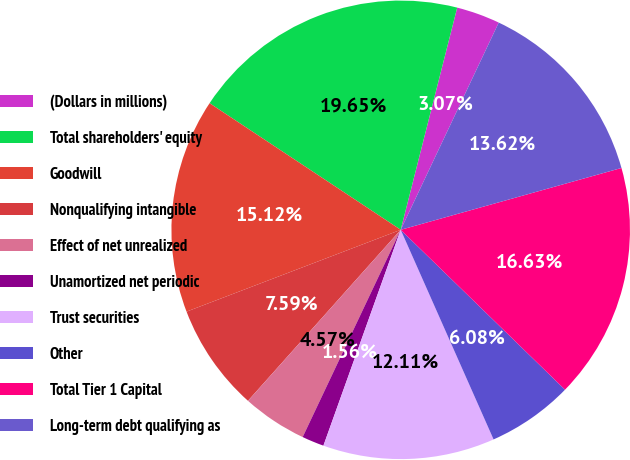Convert chart. <chart><loc_0><loc_0><loc_500><loc_500><pie_chart><fcel>(Dollars in millions)<fcel>Total shareholders' equity<fcel>Goodwill<fcel>Nonqualifying intangible<fcel>Effect of net unrealized<fcel>Unamortized net periodic<fcel>Trust securities<fcel>Other<fcel>Total Tier 1 Capital<fcel>Long-term debt qualifying as<nl><fcel>3.07%<fcel>19.65%<fcel>15.12%<fcel>7.59%<fcel>4.57%<fcel>1.56%<fcel>12.11%<fcel>6.08%<fcel>16.63%<fcel>13.62%<nl></chart> 